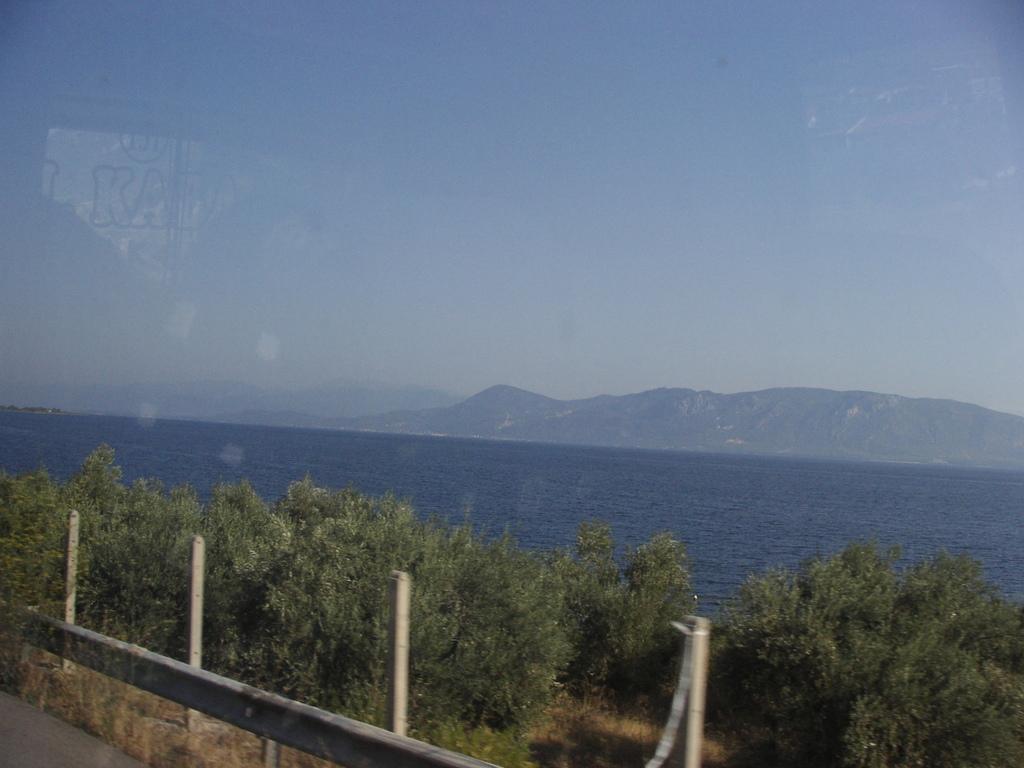How would you summarize this image in a sentence or two? These are the trees in the middle and this is water. In the long back side there are hills. 